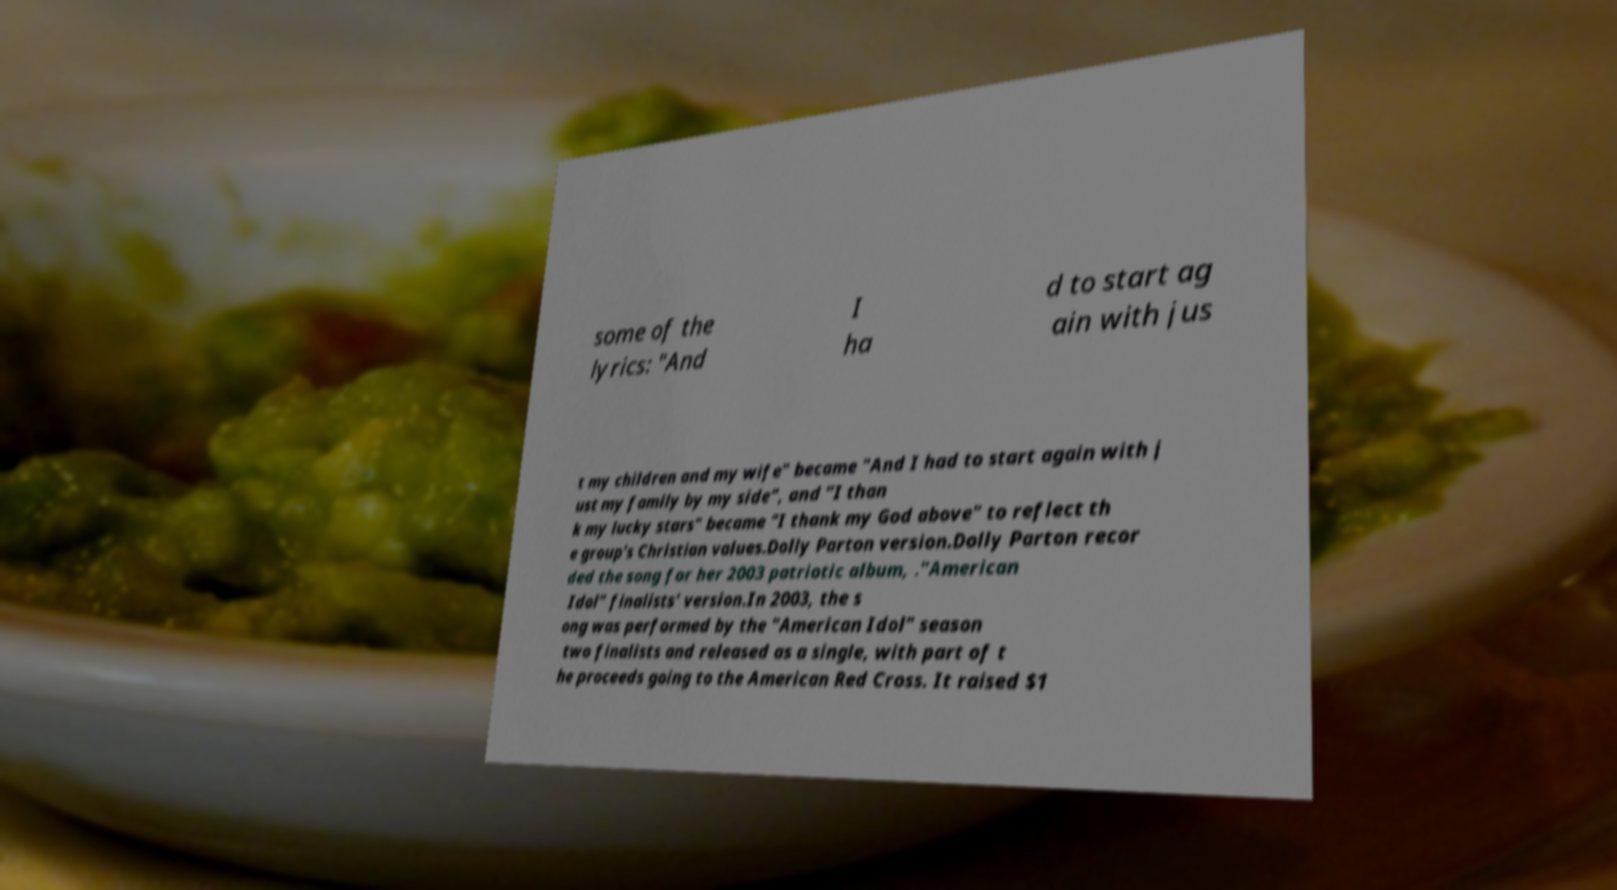Can you read and provide the text displayed in the image?This photo seems to have some interesting text. Can you extract and type it out for me? some of the lyrics: "And I ha d to start ag ain with jus t my children and my wife" became "And I had to start again with j ust my family by my side", and "I than k my lucky stars" became "I thank my God above" to reflect th e group's Christian values.Dolly Parton version.Dolly Parton recor ded the song for her 2003 patriotic album, ."American Idol" finalists' version.In 2003, the s ong was performed by the "American Idol" season two finalists and released as a single, with part of t he proceeds going to the American Red Cross. It raised $1 